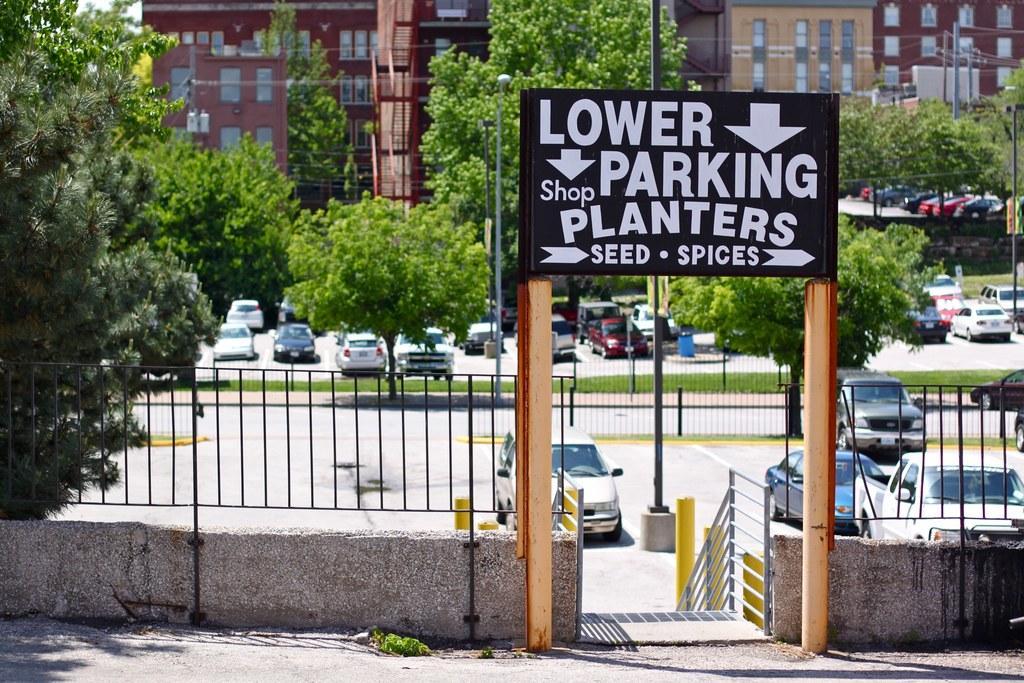Could you give a brief overview of what you see in this image? This picture is clicked outside. On the right we can see a black color board on which we can see the text and we can see the wooden poles, metal fence, handrail. In the center we can see the group of vehicles and we can see the trees, green grass, poles and cables. In the background we can see the buildings, windows of the buildings and some other objects. 